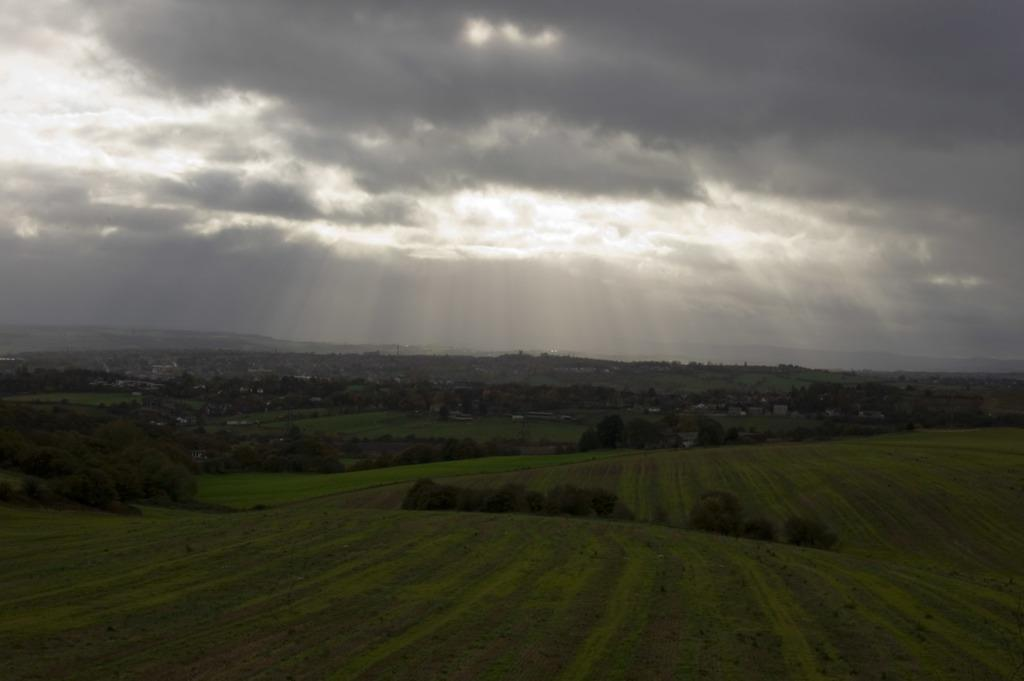What type of vegetation is on the ground in the image? There is grass on the ground in the image. What other natural elements can be seen in the image? There are trees in the image. What is visible in the background of the image? The sky is visible in the background of the image. What can be observed in the sky? Clouds are present in the sky. What type of teaching is being conducted in the image? There is no teaching or educational activity depicted in the image. How does the love between the trees manifest in the image? There is no representation of love or affection between the trees in the image. 